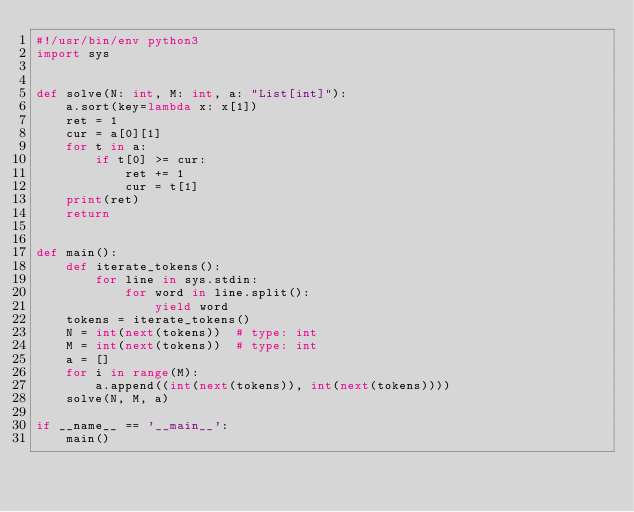Convert code to text. <code><loc_0><loc_0><loc_500><loc_500><_Python_>#!/usr/bin/env python3
import sys


def solve(N: int, M: int, a: "List[int]"):
    a.sort(key=lambda x: x[1])
    ret = 1
    cur = a[0][1]
    for t in a:
        if t[0] >= cur:
            ret += 1
            cur = t[1]
    print(ret)
    return


def main():
    def iterate_tokens():
        for line in sys.stdin:
            for word in line.split():
                yield word
    tokens = iterate_tokens()
    N = int(next(tokens))  # type: int
    M = int(next(tokens))  # type: int
    a = []
    for i in range(M):
        a.append((int(next(tokens)), int(next(tokens))))
    solve(N, M, a)

if __name__ == '__main__':
    main()
</code> 